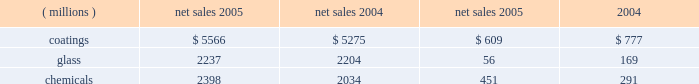Management 2019s discussion and analysis action antitrust legal settlement .
Net income for 2005 and 2004 included an aftertax charge of $ 13 million , or 8 cents a share , and $ 19 million , or 11 cents a share , respectively , to reflect the net increase in the current value of the company 2019s obligation under the ppg settlement arrangement relating to asbestos claims .
Results of business segments net sales operating income ( millions ) 2005 2004 2005 2004 .
Coatings sales increased $ 291 million or 5% ( 5 % ) in 2005 .
Sales increased 3% ( 3 % ) due to higher selling prices across all businesses except automotive ; 1% ( 1 % ) due to improved volumes as increases in our aerospace , architectural and original equipment automotive businesses offset volume declines in automotive refinish and industrial coatings ; and 1% ( 1 % ) due to the positive effects of foreign currency translation .
Operating income decreased $ 168 million in 2005 .
The adverse impact of inflation totaled $ 315 million , of which $ 245 million was attributable to higher raw material costs .
Higher year-over-year selling prices increased operating earnings by $ 169 million .
Coatings operating earnings were reduced by the $ 132 million charge for the cost of the marvin legal settlement net of insurance recoveries .
Other factors increasing coatings operating income in 2005 were the increased sales volumes described above , manufacturing efficiencies , formula cost reductions and higher other income .
Glass sales increased $ 33 million or 1% ( 1 % ) in 2005 .
Sales increased 1% ( 1 % ) due to improved volumes as increases in our automotive replacement glass , insurance and services and performance glazings ( flat glass ) businesses offset volume declines in our fiber glass and automotive original equipment glass businesses .
The positive effects of foreign currency translation were largely offset by lower selling prices primarily in our automotive replacement glass and automotive original equipment businesses .
Operating income decreased $ 113 million in 2005 .
The federal glass class action antitrust legal settlement of $ 61 million , the $ 49 million impact of rising natural gas costs and the absence of the $ 19 million gain in 2004 from the sale/ leaseback of precious metal combined to account for a reduction in operating earnings of $ 129 million .
The remaining year-over-year increase in glass operating earnings of $ 16 million resulted primarily from improved manufacturing efficiencies and lower overhead costs exceeding the adverse impact of other inflation .
Our continuing efforts in 2005 to position the fiber glass business for future growth in profitability were adversely impacted by the rise in fourth quarter natural gas prices , slightly lower year-over-year sales , lower equity earnings due to weaker pricing in the asian electronics market , and the absence of the $ 19 million gain which occurred in 2004 stemming from the sale/ leaseback of precious metals .
Despite high energy costs , we expect fiber glass earnings to improve in 2006 because of price strengthening in the asian electronics market , which began to occur in the fourth quarter of 2005 , increased cost reduction initiatives and the positive impact resulting from the start up of our new joint venture in china .
This joint venture will produce high labor content fiber glass reinforcement products and take advantage of lower labor costs , allowing us to refocus our u.s .
Production capacity on higher margin direct process products .
The 2005 operating earnings of our north american automotive oem glass business declined by $ 30 million compared with 2004 .
Significant structural changes continue to occur in the north american automotive industry , including the loss of u.s .
Market share by general motors and ford .
This has created a very challenging and competitive environment for all suppliers to the domestic oems , including our business .
About half of the decline in earnings resulted from the impact of rising natural gas costs , particularly in the fourth quarter , combined with the traditional adverse impact of year-over-year sales price reductions producing a decline in earnings that exceeded our successful efforts to reduce manufacturing costs .
The other half of the 2005 decline was due to lower sales volumes and mix and higher new program launch costs .
The challenging competitive environment and high energy prices will continue in 2006 .
Our business is working in 2006 to improve its performance through increased manufacturing efficiencies , structural cost reduction initiatives , focusing on profitable growth opportunities and improving our sales mix .
Chemicals sales increased $ 364 million or 18% ( 18 % ) in 2005 .
Sales increased 21% ( 21 % ) due to higher selling prices , primarily for chlor-alkali products , and 1% ( 1 % ) due to the combination of an acquisition in our optical products business and the positive effects of foreign currency translation .
Total volumes declined 4% ( 4 % ) as volume increases in optical products were more than offset by volume declines in chlor-alkali and fine chemicals .
Volume in chlor-alkali products and silicas were adversely impacted in the third and fourth quarters by the hurricanes .
Operating income increased $ 160 million in 2005 .
The primary factor increasing operating income was the record high selling prices in chlor-alkali .
Factors decreasing operating income were higher inflation , including $ 136 million due to increased energy and ethylene costs ; $ 34 million of direct costs related to the impact of the hurricanes ; $ 27 million due to the asset impairment charge related to our fine chemicals business ; lower sales volumes ; higher manufacturing costs and increased environmental expenses .
The increase in chemicals operating earnings occurred primarily through the first eight months of 2005 .
The hurricanes hit in september impacting volumes and costs in september through november and contributing to the rise in natural gas prices which lowered fourth quarter chemicals earnings by $ 58 million , almost 57% ( 57 % ) of the full year impact of higher natural gas prices .
The damage caused by hurricane rita resulted in the shutdown of our lake charles , la chemical plant for a total of eight days in september and an additional five 18 2005 ppg annual report and form 10-k .
What is the operating income percentage for the coatings segment in 2005? 
Computations: (609 / 5566)
Answer: 0.10941. 